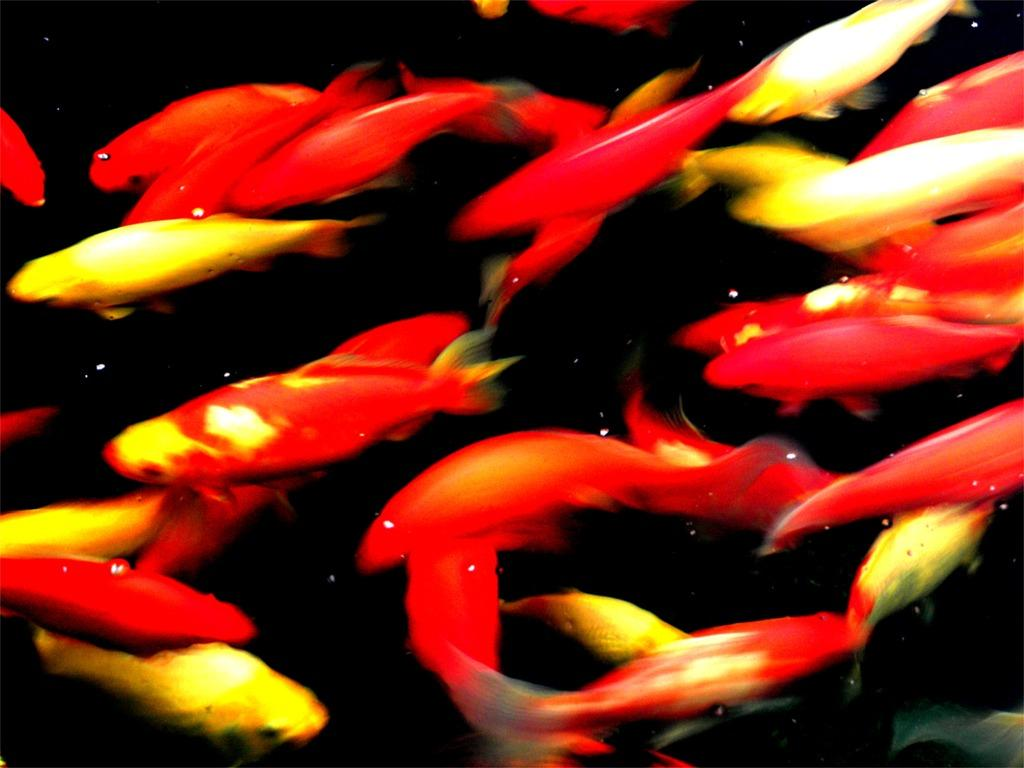What colors are the fishes in the image? The fishes in the image are red and yellow. Where are the fishes located? The fishes are in the water. What type of floor can be seen in the image? There is no floor visible in the image, as it features fishes in the water. 